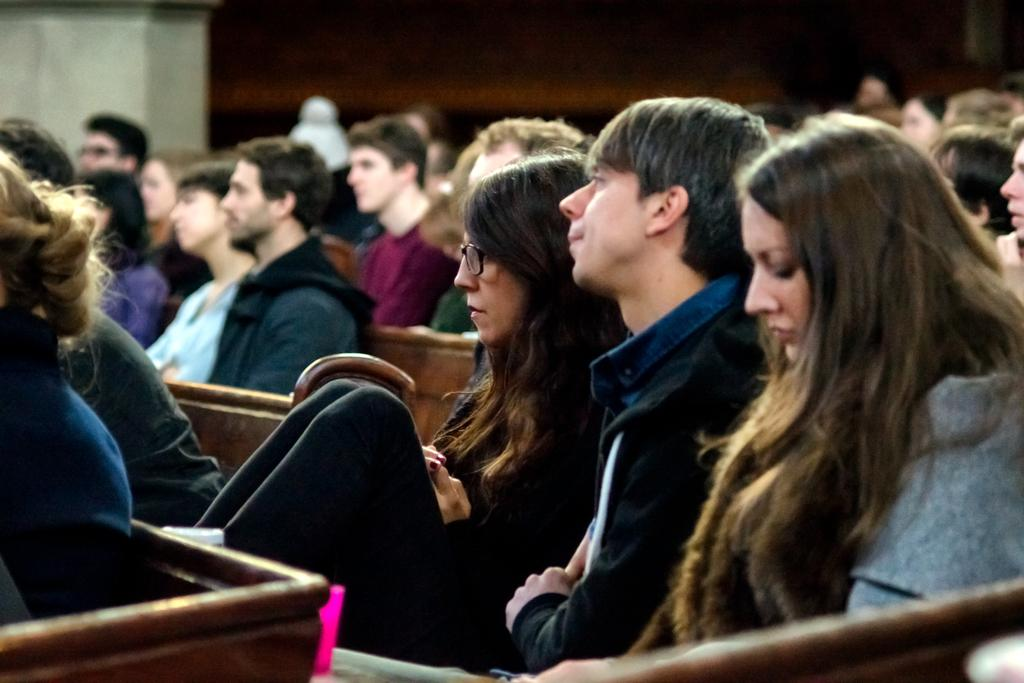What are the people in the image doing? The people in the image are sitting. What can be seen in the background of the image? There is a wall visible in the background of the image. How many horses are visible in the image? There are no horses present in the image. What type of blade is being used by the people in the image? There is no blade visible in the image; the people are simply sitting. 